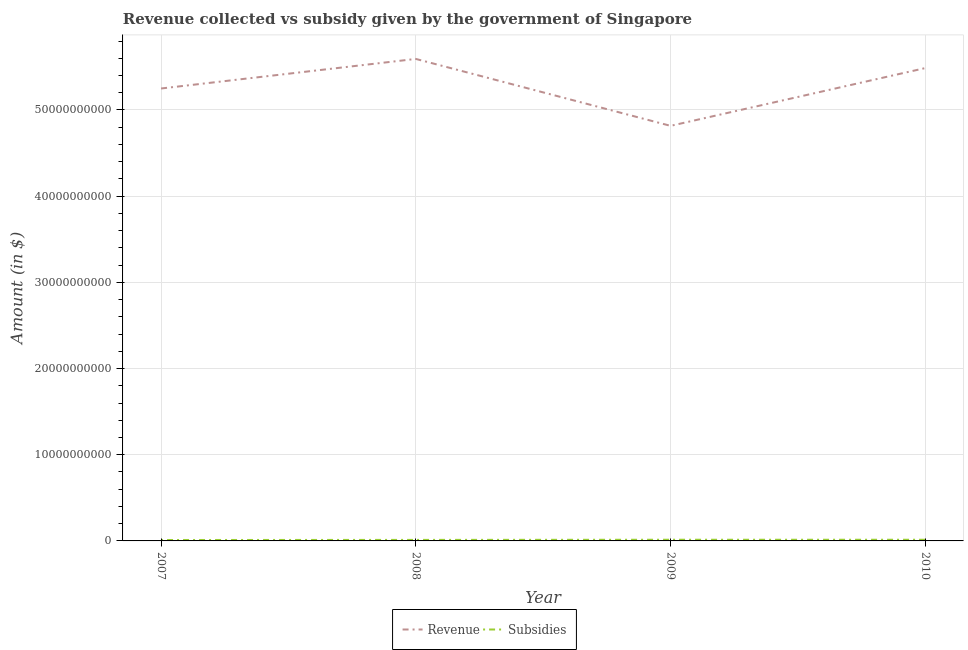Does the line corresponding to amount of subsidies given intersect with the line corresponding to amount of revenue collected?
Offer a very short reply. No. Is the number of lines equal to the number of legend labels?
Your answer should be compact. Yes. What is the amount of subsidies given in 2010?
Provide a succinct answer. 1.36e+08. Across all years, what is the maximum amount of revenue collected?
Ensure brevity in your answer.  5.59e+1. Across all years, what is the minimum amount of subsidies given?
Offer a very short reply. 1.07e+08. In which year was the amount of subsidies given maximum?
Offer a very short reply. 2009. What is the total amount of revenue collected in the graph?
Make the answer very short. 2.11e+11. What is the difference between the amount of revenue collected in 2007 and that in 2010?
Keep it short and to the point. -2.37e+09. What is the difference between the amount of subsidies given in 2009 and the amount of revenue collected in 2010?
Make the answer very short. -5.47e+1. What is the average amount of revenue collected per year?
Your answer should be compact. 5.29e+1. In the year 2009, what is the difference between the amount of revenue collected and amount of subsidies given?
Keep it short and to the point. 4.80e+1. In how many years, is the amount of subsidies given greater than 28000000000 $?
Your answer should be compact. 0. What is the ratio of the amount of revenue collected in 2007 to that in 2008?
Ensure brevity in your answer.  0.94. Is the amount of revenue collected in 2009 less than that in 2010?
Make the answer very short. Yes. What is the difference between the highest and the second highest amount of revenue collected?
Your answer should be very brief. 1.06e+09. What is the difference between the highest and the lowest amount of revenue collected?
Keep it short and to the point. 7.76e+09. In how many years, is the amount of revenue collected greater than the average amount of revenue collected taken over all years?
Keep it short and to the point. 2. Is the sum of the amount of subsidies given in 2007 and 2010 greater than the maximum amount of revenue collected across all years?
Provide a succinct answer. No. Does the amount of revenue collected monotonically increase over the years?
Offer a very short reply. No. What is the difference between two consecutive major ticks on the Y-axis?
Provide a succinct answer. 1.00e+1. Are the values on the major ticks of Y-axis written in scientific E-notation?
Keep it short and to the point. No. Does the graph contain any zero values?
Ensure brevity in your answer.  No. Where does the legend appear in the graph?
Your response must be concise. Bottom center. How many legend labels are there?
Your response must be concise. 2. What is the title of the graph?
Offer a very short reply. Revenue collected vs subsidy given by the government of Singapore. Does "Commercial bank branches" appear as one of the legend labels in the graph?
Ensure brevity in your answer.  No. What is the label or title of the Y-axis?
Provide a succinct answer. Amount (in $). What is the Amount (in $) in Revenue in 2007?
Your response must be concise. 5.25e+1. What is the Amount (in $) in Subsidies in 2007?
Make the answer very short. 1.07e+08. What is the Amount (in $) in Revenue in 2008?
Provide a short and direct response. 5.59e+1. What is the Amount (in $) of Subsidies in 2008?
Keep it short and to the point. 1.19e+08. What is the Amount (in $) of Revenue in 2009?
Make the answer very short. 4.82e+1. What is the Amount (in $) in Subsidies in 2009?
Make the answer very short. 1.37e+08. What is the Amount (in $) in Revenue in 2010?
Keep it short and to the point. 5.49e+1. What is the Amount (in $) in Subsidies in 2010?
Provide a short and direct response. 1.36e+08. Across all years, what is the maximum Amount (in $) in Revenue?
Provide a succinct answer. 5.59e+1. Across all years, what is the maximum Amount (in $) of Subsidies?
Provide a short and direct response. 1.37e+08. Across all years, what is the minimum Amount (in $) in Revenue?
Your answer should be compact. 4.82e+1. Across all years, what is the minimum Amount (in $) in Subsidies?
Provide a short and direct response. 1.07e+08. What is the total Amount (in $) in Revenue in the graph?
Make the answer very short. 2.11e+11. What is the total Amount (in $) of Subsidies in the graph?
Keep it short and to the point. 4.99e+08. What is the difference between the Amount (in $) in Revenue in 2007 and that in 2008?
Your answer should be compact. -3.43e+09. What is the difference between the Amount (in $) of Subsidies in 2007 and that in 2008?
Make the answer very short. -1.20e+07. What is the difference between the Amount (in $) in Revenue in 2007 and that in 2009?
Provide a succinct answer. 4.33e+09. What is the difference between the Amount (in $) of Subsidies in 2007 and that in 2009?
Make the answer very short. -3.00e+07. What is the difference between the Amount (in $) in Revenue in 2007 and that in 2010?
Offer a terse response. -2.37e+09. What is the difference between the Amount (in $) of Subsidies in 2007 and that in 2010?
Offer a terse response. -2.87e+07. What is the difference between the Amount (in $) of Revenue in 2008 and that in 2009?
Offer a terse response. 7.76e+09. What is the difference between the Amount (in $) in Subsidies in 2008 and that in 2009?
Your answer should be compact. -1.80e+07. What is the difference between the Amount (in $) in Revenue in 2008 and that in 2010?
Your answer should be compact. 1.06e+09. What is the difference between the Amount (in $) in Subsidies in 2008 and that in 2010?
Give a very brief answer. -1.67e+07. What is the difference between the Amount (in $) of Revenue in 2009 and that in 2010?
Offer a terse response. -6.70e+09. What is the difference between the Amount (in $) of Subsidies in 2009 and that in 2010?
Keep it short and to the point. 1.30e+06. What is the difference between the Amount (in $) in Revenue in 2007 and the Amount (in $) in Subsidies in 2008?
Offer a terse response. 5.24e+1. What is the difference between the Amount (in $) in Revenue in 2007 and the Amount (in $) in Subsidies in 2009?
Make the answer very short. 5.24e+1. What is the difference between the Amount (in $) of Revenue in 2007 and the Amount (in $) of Subsidies in 2010?
Offer a terse response. 5.24e+1. What is the difference between the Amount (in $) of Revenue in 2008 and the Amount (in $) of Subsidies in 2009?
Provide a short and direct response. 5.58e+1. What is the difference between the Amount (in $) of Revenue in 2008 and the Amount (in $) of Subsidies in 2010?
Your answer should be compact. 5.58e+1. What is the difference between the Amount (in $) in Revenue in 2009 and the Amount (in $) in Subsidies in 2010?
Your answer should be very brief. 4.80e+1. What is the average Amount (in $) of Revenue per year?
Ensure brevity in your answer.  5.29e+1. What is the average Amount (in $) in Subsidies per year?
Keep it short and to the point. 1.25e+08. In the year 2007, what is the difference between the Amount (in $) of Revenue and Amount (in $) of Subsidies?
Your answer should be very brief. 5.24e+1. In the year 2008, what is the difference between the Amount (in $) of Revenue and Amount (in $) of Subsidies?
Your answer should be compact. 5.58e+1. In the year 2009, what is the difference between the Amount (in $) of Revenue and Amount (in $) of Subsidies?
Offer a terse response. 4.80e+1. In the year 2010, what is the difference between the Amount (in $) in Revenue and Amount (in $) in Subsidies?
Keep it short and to the point. 5.47e+1. What is the ratio of the Amount (in $) in Revenue in 2007 to that in 2008?
Provide a short and direct response. 0.94. What is the ratio of the Amount (in $) in Subsidies in 2007 to that in 2008?
Offer a very short reply. 0.9. What is the ratio of the Amount (in $) in Revenue in 2007 to that in 2009?
Offer a terse response. 1.09. What is the ratio of the Amount (in $) in Subsidies in 2007 to that in 2009?
Provide a succinct answer. 0.78. What is the ratio of the Amount (in $) in Revenue in 2007 to that in 2010?
Make the answer very short. 0.96. What is the ratio of the Amount (in $) of Subsidies in 2007 to that in 2010?
Offer a very short reply. 0.79. What is the ratio of the Amount (in $) of Revenue in 2008 to that in 2009?
Offer a terse response. 1.16. What is the ratio of the Amount (in $) in Subsidies in 2008 to that in 2009?
Ensure brevity in your answer.  0.87. What is the ratio of the Amount (in $) in Revenue in 2008 to that in 2010?
Provide a succinct answer. 1.02. What is the ratio of the Amount (in $) in Subsidies in 2008 to that in 2010?
Ensure brevity in your answer.  0.88. What is the ratio of the Amount (in $) in Revenue in 2009 to that in 2010?
Provide a succinct answer. 0.88. What is the ratio of the Amount (in $) in Subsidies in 2009 to that in 2010?
Your answer should be compact. 1.01. What is the difference between the highest and the second highest Amount (in $) in Revenue?
Your response must be concise. 1.06e+09. What is the difference between the highest and the second highest Amount (in $) of Subsidies?
Keep it short and to the point. 1.30e+06. What is the difference between the highest and the lowest Amount (in $) in Revenue?
Keep it short and to the point. 7.76e+09. What is the difference between the highest and the lowest Amount (in $) of Subsidies?
Ensure brevity in your answer.  3.00e+07. 